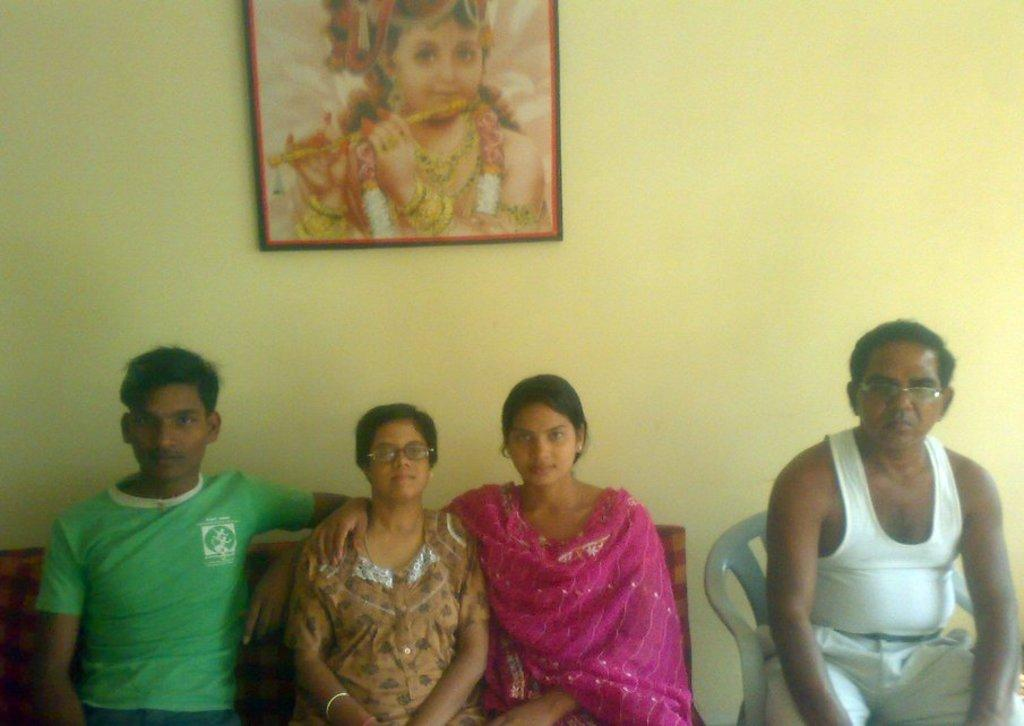How many people are sitting on the sofa in the image? There are three persons sitting on a sofa on the left side of the image. What is the man on the right side of the image wearing? The man on the right side of the image is wearing glasses. What can be seen on the wall in the background of the image? There is a wall with a photo frame in the background of the image. What type of reaction does the cream have when it is poured into the father's coffee in the image? There is no cream or father present in the image, so this reaction cannot be observed. 